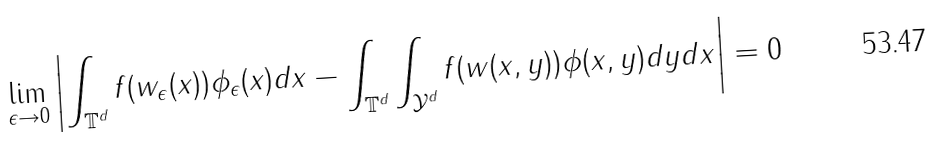<formula> <loc_0><loc_0><loc_500><loc_500>\lim _ { \epsilon \rightarrow 0 } \left | \int _ { \mathbb { T } ^ { d } } f ( w _ { \epsilon } ( x ) ) \phi _ { \epsilon } ( x ) d x - \int _ { \mathbb { T } ^ { d } } \int _ { \mathcal { Y } ^ { d } } f ( w ( x , y ) ) \phi ( x , y ) d y d x \right | = 0</formula> 